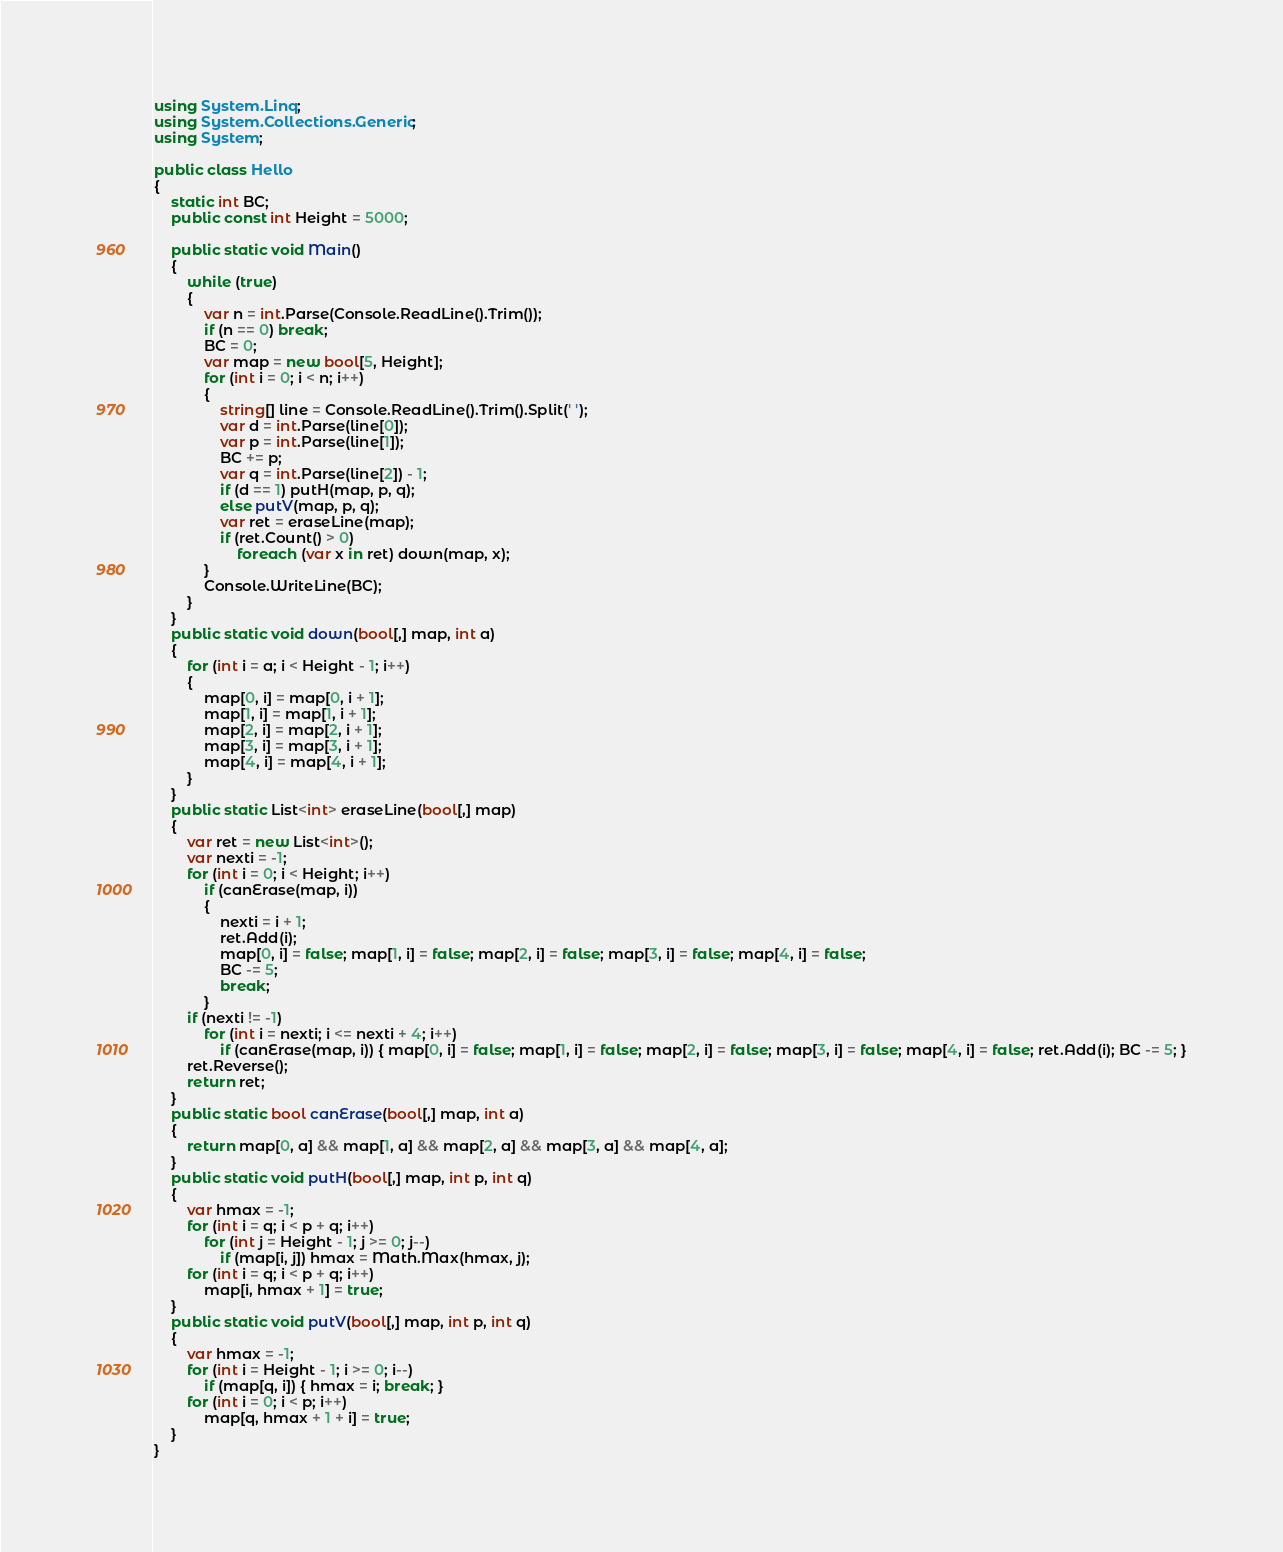Convert code to text. <code><loc_0><loc_0><loc_500><loc_500><_C#_>using System.Linq;
using System.Collections.Generic;
using System;

public class Hello
{
    static int BC;
    public const int Height = 5000;

    public static void Main()
    {
        while (true)
        {
            var n = int.Parse(Console.ReadLine().Trim());
            if (n == 0) break;
            BC = 0;
            var map = new bool[5, Height];
            for (int i = 0; i < n; i++)
            {
                string[] line = Console.ReadLine().Trim().Split(' ');
                var d = int.Parse(line[0]);
                var p = int.Parse(line[1]);
                BC += p;
                var q = int.Parse(line[2]) - 1;
                if (d == 1) putH(map, p, q);
                else putV(map, p, q);
                var ret = eraseLine(map);
                if (ret.Count() > 0)
                    foreach (var x in ret) down(map, x);
            }
            Console.WriteLine(BC);
        }
    }
    public static void down(bool[,] map, int a)
    {
        for (int i = a; i < Height - 1; i++)
        {
            map[0, i] = map[0, i + 1];
            map[1, i] = map[1, i + 1];
            map[2, i] = map[2, i + 1];
            map[3, i] = map[3, i + 1];
            map[4, i] = map[4, i + 1];
        }
    }
    public static List<int> eraseLine(bool[,] map)
    {
        var ret = new List<int>();
        var nexti = -1;
        for (int i = 0; i < Height; i++)
            if (canErase(map, i))
            {
                nexti = i + 1;
                ret.Add(i);
                map[0, i] = false; map[1, i] = false; map[2, i] = false; map[3, i] = false; map[4, i] = false;
                BC -= 5;
                break;
            }
        if (nexti != -1)
            for (int i = nexti; i <= nexti + 4; i++)
                if (canErase(map, i)) { map[0, i] = false; map[1, i] = false; map[2, i] = false; map[3, i] = false; map[4, i] = false; ret.Add(i); BC -= 5; }
        ret.Reverse();
        return ret;
    }
    public static bool canErase(bool[,] map, int a)
    {
        return map[0, a] && map[1, a] && map[2, a] && map[3, a] && map[4, a];
    }
    public static void putH(bool[,] map, int p, int q)
    {
        var hmax = -1;
        for (int i = q; i < p + q; i++)
            for (int j = Height - 1; j >= 0; j--)
                if (map[i, j]) hmax = Math.Max(hmax, j);
        for (int i = q; i < p + q; i++)
            map[i, hmax + 1] = true;
    }
    public static void putV(bool[,] map, int p, int q)
    {
        var hmax = -1;
        for (int i = Height - 1; i >= 0; i--)
            if (map[q, i]) { hmax = i; break; }
        for (int i = 0; i < p; i++)
            map[q, hmax + 1 + i] = true;
    }
}

</code> 